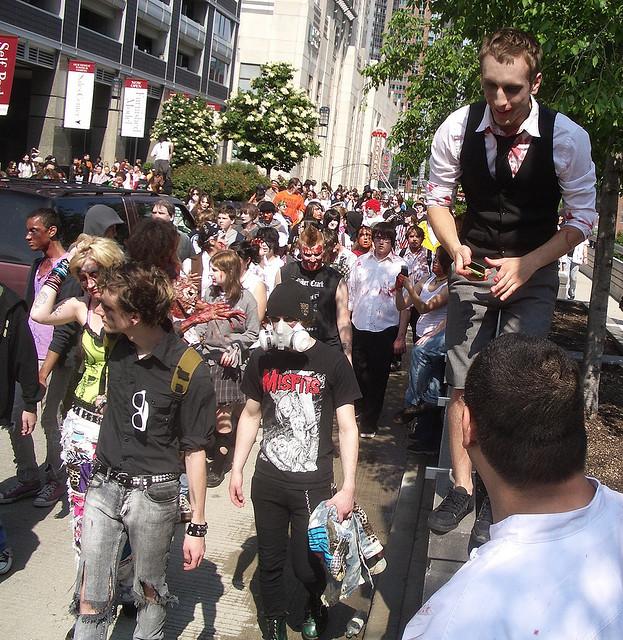Was this picture taken indoors?
Keep it brief. No. Is the man in the vest a magician?
Short answer required. No. What band is on the t-shirt of the guy closest to the camera?
Give a very brief answer. Misfits. 